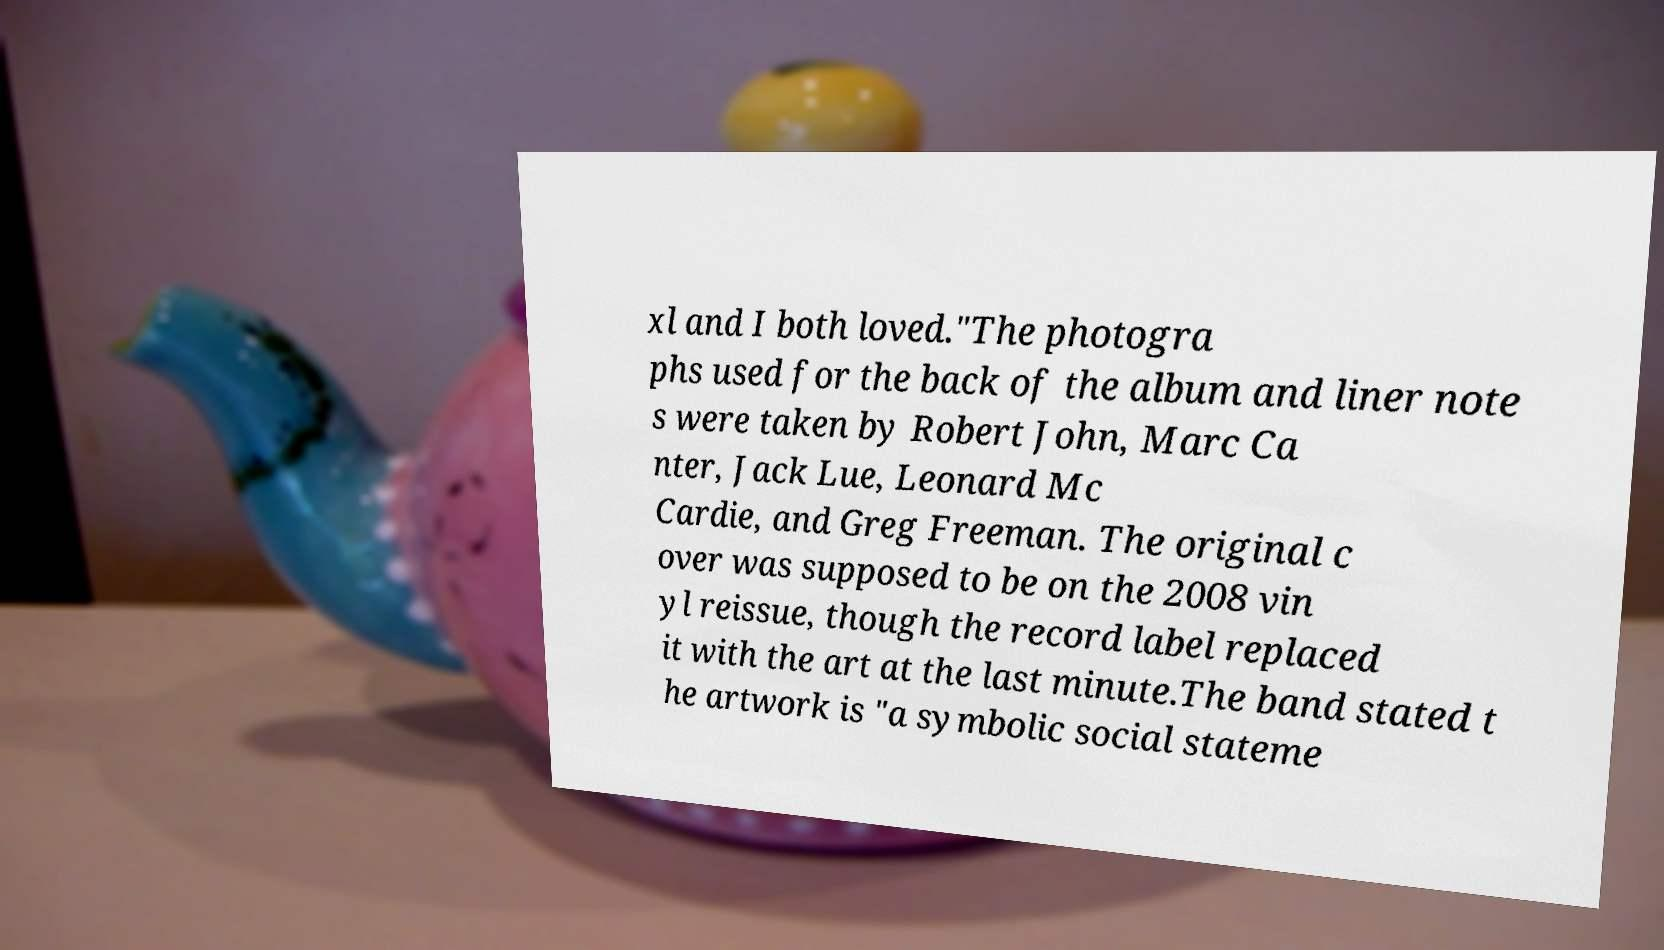What messages or text are displayed in this image? I need them in a readable, typed format. xl and I both loved."The photogra phs used for the back of the album and liner note s were taken by Robert John, Marc Ca nter, Jack Lue, Leonard Mc Cardie, and Greg Freeman. The original c over was supposed to be on the 2008 vin yl reissue, though the record label replaced it with the art at the last minute.The band stated t he artwork is "a symbolic social stateme 